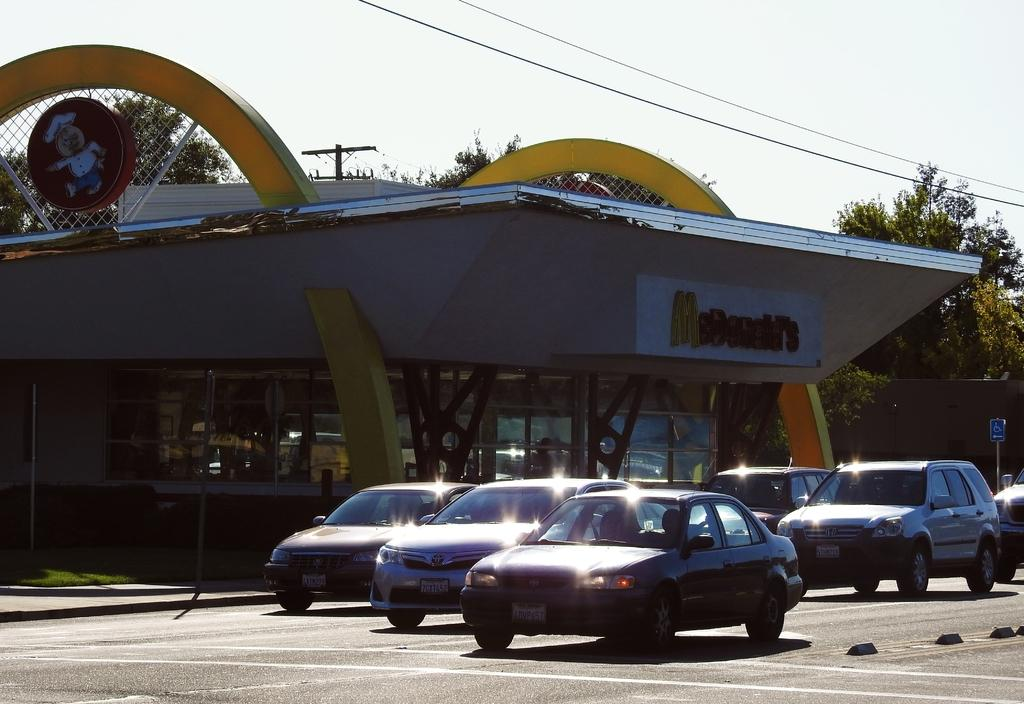What type of structure is present in the image? There is a building in the image. What can be seen on the building? There is a name board and a sign board on the building. What is visible near the building? There is a mesh, an electric pole, and electric cables in the image. What is present on the road in the image? There are motor vehicles on the road in the image. What is the ground like in the image? The ground is visible in the image. What type of bulb is being discussed in the meeting in the image? There is no meeting or bulb present in the image. How many legs can be seen on the people in the image? There are no people visible in the image, so it is impossible to determine the number of legs. 